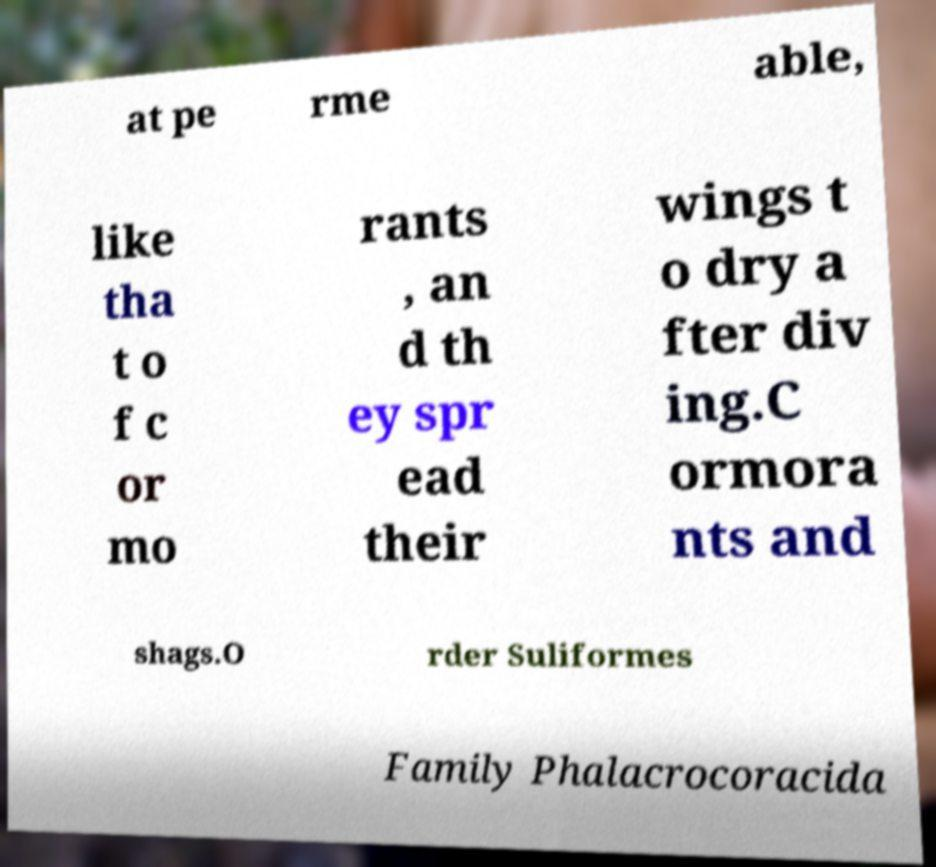For documentation purposes, I need the text within this image transcribed. Could you provide that? at pe rme able, like tha t o f c or mo rants , an d th ey spr ead their wings t o dry a fter div ing.C ormora nts and shags.O rder Suliformes Family Phalacrocoracida 